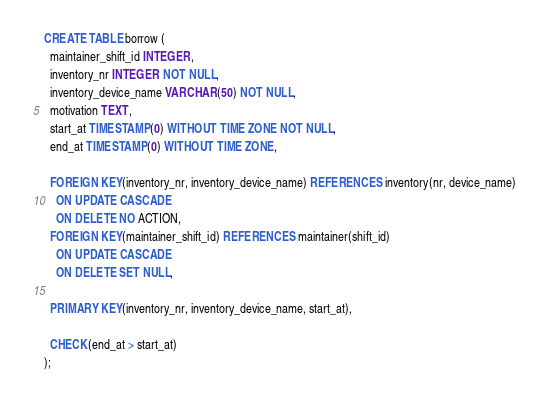Convert code to text. <code><loc_0><loc_0><loc_500><loc_500><_SQL_>CREATE TABLE borrow (
  maintainer_shift_id INTEGER,
  inventory_nr INTEGER NOT NULL,
  inventory_device_name VARCHAR(50) NOT NULL, 
  motivation TEXT,
  start_at TIMESTAMP(0) WITHOUT TIME ZONE NOT NULL,
  end_at TIMESTAMP(0) WITHOUT TIME ZONE,

  FOREIGN KEY(inventory_nr, inventory_device_name) REFERENCES inventory(nr, device_name)
    ON UPDATE CASCADE
    ON DELETE NO ACTION,
  FOREIGN KEY(maintainer_shift_id) REFERENCES maintainer(shift_id)
    ON UPDATE CASCADE
    ON DELETE SET NULL,

  PRIMARY KEY(inventory_nr, inventory_device_name, start_at),

  CHECK(end_at > start_at)
);
</code> 